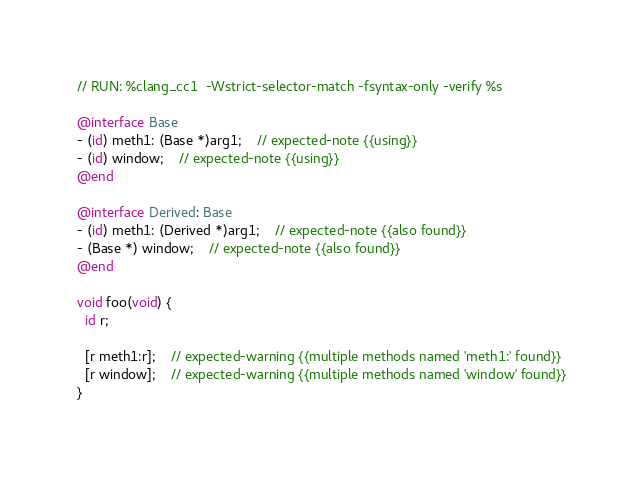<code> <loc_0><loc_0><loc_500><loc_500><_ObjectiveC_>// RUN: %clang_cc1  -Wstrict-selector-match -fsyntax-only -verify %s

@interface Base
- (id) meth1: (Base *)arg1; 	// expected-note {{using}}
- (id) window;	// expected-note {{using}}
@end

@interface Derived: Base
- (id) meth1: (Derived *)arg1;	// expected-note {{also found}}
- (Base *) window;	// expected-note {{also found}}
@end

void foo(void) {
  id r;

  [r meth1:r];	// expected-warning {{multiple methods named 'meth1:' found}}
  [r window]; 	// expected-warning {{multiple methods named 'window' found}}
}
</code> 